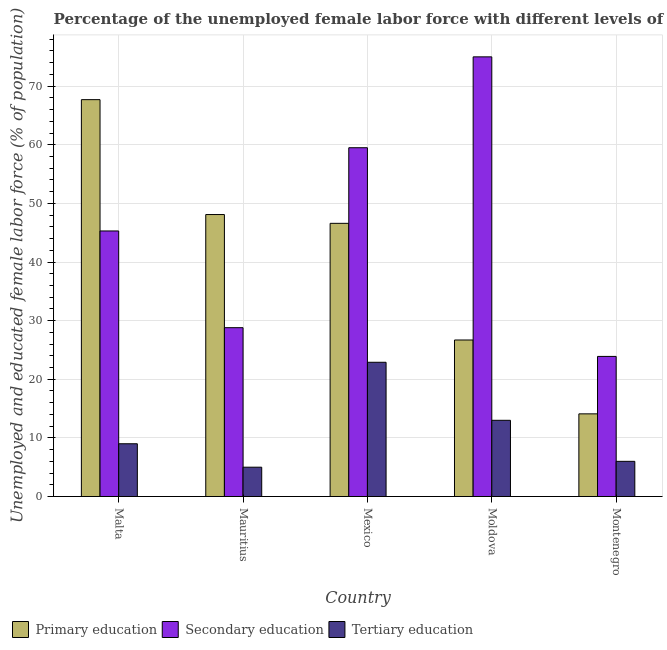Are the number of bars on each tick of the X-axis equal?
Provide a short and direct response. Yes. What is the label of the 5th group of bars from the left?
Provide a short and direct response. Montenegro. In how many cases, is the number of bars for a given country not equal to the number of legend labels?
Your answer should be very brief. 0. What is the percentage of female labor force who received secondary education in Malta?
Your answer should be compact. 45.3. Across all countries, what is the maximum percentage of female labor force who received secondary education?
Keep it short and to the point. 75. Across all countries, what is the minimum percentage of female labor force who received tertiary education?
Give a very brief answer. 5. In which country was the percentage of female labor force who received tertiary education minimum?
Provide a short and direct response. Mauritius. What is the total percentage of female labor force who received secondary education in the graph?
Offer a very short reply. 232.5. What is the difference between the percentage of female labor force who received primary education in Mauritius and that in Moldova?
Offer a terse response. 21.4. What is the average percentage of female labor force who received secondary education per country?
Your response must be concise. 46.5. What is the difference between the percentage of female labor force who received tertiary education and percentage of female labor force who received secondary education in Montenegro?
Provide a short and direct response. -17.9. In how many countries, is the percentage of female labor force who received tertiary education greater than 22 %?
Give a very brief answer. 1. What is the ratio of the percentage of female labor force who received primary education in Mexico to that in Moldova?
Provide a succinct answer. 1.75. Is the percentage of female labor force who received tertiary education in Mexico less than that in Montenegro?
Make the answer very short. No. What is the difference between the highest and the second highest percentage of female labor force who received tertiary education?
Your answer should be compact. 9.9. What is the difference between the highest and the lowest percentage of female labor force who received tertiary education?
Keep it short and to the point. 17.9. Is the sum of the percentage of female labor force who received secondary education in Mauritius and Mexico greater than the maximum percentage of female labor force who received tertiary education across all countries?
Give a very brief answer. Yes. What does the 3rd bar from the left in Montenegro represents?
Keep it short and to the point. Tertiary education. What does the 1st bar from the right in Mauritius represents?
Make the answer very short. Tertiary education. Does the graph contain any zero values?
Offer a terse response. No. Does the graph contain grids?
Keep it short and to the point. Yes. Where does the legend appear in the graph?
Keep it short and to the point. Bottom left. How are the legend labels stacked?
Offer a very short reply. Horizontal. What is the title of the graph?
Your answer should be compact. Percentage of the unemployed female labor force with different levels of education in countries. What is the label or title of the X-axis?
Offer a very short reply. Country. What is the label or title of the Y-axis?
Give a very brief answer. Unemployed and educated female labor force (% of population). What is the Unemployed and educated female labor force (% of population) in Primary education in Malta?
Keep it short and to the point. 67.7. What is the Unemployed and educated female labor force (% of population) in Secondary education in Malta?
Offer a very short reply. 45.3. What is the Unemployed and educated female labor force (% of population) in Primary education in Mauritius?
Ensure brevity in your answer.  48.1. What is the Unemployed and educated female labor force (% of population) in Secondary education in Mauritius?
Keep it short and to the point. 28.8. What is the Unemployed and educated female labor force (% of population) of Primary education in Mexico?
Provide a short and direct response. 46.6. What is the Unemployed and educated female labor force (% of population) of Secondary education in Mexico?
Ensure brevity in your answer.  59.5. What is the Unemployed and educated female labor force (% of population) in Tertiary education in Mexico?
Make the answer very short. 22.9. What is the Unemployed and educated female labor force (% of population) of Primary education in Moldova?
Provide a short and direct response. 26.7. What is the Unemployed and educated female labor force (% of population) in Tertiary education in Moldova?
Provide a short and direct response. 13. What is the Unemployed and educated female labor force (% of population) in Primary education in Montenegro?
Your response must be concise. 14.1. What is the Unemployed and educated female labor force (% of population) of Secondary education in Montenegro?
Keep it short and to the point. 23.9. What is the Unemployed and educated female labor force (% of population) of Tertiary education in Montenegro?
Keep it short and to the point. 6. Across all countries, what is the maximum Unemployed and educated female labor force (% of population) in Primary education?
Give a very brief answer. 67.7. Across all countries, what is the maximum Unemployed and educated female labor force (% of population) of Tertiary education?
Offer a very short reply. 22.9. Across all countries, what is the minimum Unemployed and educated female labor force (% of population) in Primary education?
Your answer should be very brief. 14.1. Across all countries, what is the minimum Unemployed and educated female labor force (% of population) in Secondary education?
Offer a very short reply. 23.9. Across all countries, what is the minimum Unemployed and educated female labor force (% of population) in Tertiary education?
Provide a succinct answer. 5. What is the total Unemployed and educated female labor force (% of population) in Primary education in the graph?
Make the answer very short. 203.2. What is the total Unemployed and educated female labor force (% of population) of Secondary education in the graph?
Provide a succinct answer. 232.5. What is the total Unemployed and educated female labor force (% of population) in Tertiary education in the graph?
Keep it short and to the point. 55.9. What is the difference between the Unemployed and educated female labor force (% of population) of Primary education in Malta and that in Mauritius?
Ensure brevity in your answer.  19.6. What is the difference between the Unemployed and educated female labor force (% of population) of Primary education in Malta and that in Mexico?
Offer a very short reply. 21.1. What is the difference between the Unemployed and educated female labor force (% of population) of Secondary education in Malta and that in Mexico?
Offer a terse response. -14.2. What is the difference between the Unemployed and educated female labor force (% of population) in Primary education in Malta and that in Moldova?
Provide a succinct answer. 41. What is the difference between the Unemployed and educated female labor force (% of population) in Secondary education in Malta and that in Moldova?
Offer a terse response. -29.7. What is the difference between the Unemployed and educated female labor force (% of population) of Tertiary education in Malta and that in Moldova?
Give a very brief answer. -4. What is the difference between the Unemployed and educated female labor force (% of population) of Primary education in Malta and that in Montenegro?
Your answer should be compact. 53.6. What is the difference between the Unemployed and educated female labor force (% of population) in Secondary education in Malta and that in Montenegro?
Offer a very short reply. 21.4. What is the difference between the Unemployed and educated female labor force (% of population) of Primary education in Mauritius and that in Mexico?
Provide a succinct answer. 1.5. What is the difference between the Unemployed and educated female labor force (% of population) in Secondary education in Mauritius and that in Mexico?
Keep it short and to the point. -30.7. What is the difference between the Unemployed and educated female labor force (% of population) of Tertiary education in Mauritius and that in Mexico?
Offer a very short reply. -17.9. What is the difference between the Unemployed and educated female labor force (% of population) of Primary education in Mauritius and that in Moldova?
Your answer should be compact. 21.4. What is the difference between the Unemployed and educated female labor force (% of population) in Secondary education in Mauritius and that in Moldova?
Offer a very short reply. -46.2. What is the difference between the Unemployed and educated female labor force (% of population) in Primary education in Mauritius and that in Montenegro?
Keep it short and to the point. 34. What is the difference between the Unemployed and educated female labor force (% of population) in Secondary education in Mexico and that in Moldova?
Keep it short and to the point. -15.5. What is the difference between the Unemployed and educated female labor force (% of population) in Primary education in Mexico and that in Montenegro?
Give a very brief answer. 32.5. What is the difference between the Unemployed and educated female labor force (% of population) of Secondary education in Mexico and that in Montenegro?
Give a very brief answer. 35.6. What is the difference between the Unemployed and educated female labor force (% of population) of Tertiary education in Mexico and that in Montenegro?
Your answer should be very brief. 16.9. What is the difference between the Unemployed and educated female labor force (% of population) of Secondary education in Moldova and that in Montenegro?
Your answer should be compact. 51.1. What is the difference between the Unemployed and educated female labor force (% of population) of Primary education in Malta and the Unemployed and educated female labor force (% of population) of Secondary education in Mauritius?
Your answer should be compact. 38.9. What is the difference between the Unemployed and educated female labor force (% of population) in Primary education in Malta and the Unemployed and educated female labor force (% of population) in Tertiary education in Mauritius?
Ensure brevity in your answer.  62.7. What is the difference between the Unemployed and educated female labor force (% of population) in Secondary education in Malta and the Unemployed and educated female labor force (% of population) in Tertiary education in Mauritius?
Keep it short and to the point. 40.3. What is the difference between the Unemployed and educated female labor force (% of population) of Primary education in Malta and the Unemployed and educated female labor force (% of population) of Secondary education in Mexico?
Offer a very short reply. 8.2. What is the difference between the Unemployed and educated female labor force (% of population) of Primary education in Malta and the Unemployed and educated female labor force (% of population) of Tertiary education in Mexico?
Offer a very short reply. 44.8. What is the difference between the Unemployed and educated female labor force (% of population) in Secondary education in Malta and the Unemployed and educated female labor force (% of population) in Tertiary education in Mexico?
Your answer should be compact. 22.4. What is the difference between the Unemployed and educated female labor force (% of population) in Primary education in Malta and the Unemployed and educated female labor force (% of population) in Secondary education in Moldova?
Give a very brief answer. -7.3. What is the difference between the Unemployed and educated female labor force (% of population) in Primary education in Malta and the Unemployed and educated female labor force (% of population) in Tertiary education in Moldova?
Give a very brief answer. 54.7. What is the difference between the Unemployed and educated female labor force (% of population) in Secondary education in Malta and the Unemployed and educated female labor force (% of population) in Tertiary education in Moldova?
Provide a short and direct response. 32.3. What is the difference between the Unemployed and educated female labor force (% of population) of Primary education in Malta and the Unemployed and educated female labor force (% of population) of Secondary education in Montenegro?
Provide a short and direct response. 43.8. What is the difference between the Unemployed and educated female labor force (% of population) of Primary education in Malta and the Unemployed and educated female labor force (% of population) of Tertiary education in Montenegro?
Your answer should be very brief. 61.7. What is the difference between the Unemployed and educated female labor force (% of population) in Secondary education in Malta and the Unemployed and educated female labor force (% of population) in Tertiary education in Montenegro?
Keep it short and to the point. 39.3. What is the difference between the Unemployed and educated female labor force (% of population) of Primary education in Mauritius and the Unemployed and educated female labor force (% of population) of Secondary education in Mexico?
Your answer should be compact. -11.4. What is the difference between the Unemployed and educated female labor force (% of population) in Primary education in Mauritius and the Unemployed and educated female labor force (% of population) in Tertiary education in Mexico?
Ensure brevity in your answer.  25.2. What is the difference between the Unemployed and educated female labor force (% of population) of Primary education in Mauritius and the Unemployed and educated female labor force (% of population) of Secondary education in Moldova?
Provide a short and direct response. -26.9. What is the difference between the Unemployed and educated female labor force (% of population) in Primary education in Mauritius and the Unemployed and educated female labor force (% of population) in Tertiary education in Moldova?
Provide a succinct answer. 35.1. What is the difference between the Unemployed and educated female labor force (% of population) in Secondary education in Mauritius and the Unemployed and educated female labor force (% of population) in Tertiary education in Moldova?
Offer a very short reply. 15.8. What is the difference between the Unemployed and educated female labor force (% of population) of Primary education in Mauritius and the Unemployed and educated female labor force (% of population) of Secondary education in Montenegro?
Offer a very short reply. 24.2. What is the difference between the Unemployed and educated female labor force (% of population) in Primary education in Mauritius and the Unemployed and educated female labor force (% of population) in Tertiary education in Montenegro?
Make the answer very short. 42.1. What is the difference between the Unemployed and educated female labor force (% of population) in Secondary education in Mauritius and the Unemployed and educated female labor force (% of population) in Tertiary education in Montenegro?
Keep it short and to the point. 22.8. What is the difference between the Unemployed and educated female labor force (% of population) in Primary education in Mexico and the Unemployed and educated female labor force (% of population) in Secondary education in Moldova?
Offer a terse response. -28.4. What is the difference between the Unemployed and educated female labor force (% of population) of Primary education in Mexico and the Unemployed and educated female labor force (% of population) of Tertiary education in Moldova?
Give a very brief answer. 33.6. What is the difference between the Unemployed and educated female labor force (% of population) of Secondary education in Mexico and the Unemployed and educated female labor force (% of population) of Tertiary education in Moldova?
Offer a terse response. 46.5. What is the difference between the Unemployed and educated female labor force (% of population) in Primary education in Mexico and the Unemployed and educated female labor force (% of population) in Secondary education in Montenegro?
Your response must be concise. 22.7. What is the difference between the Unemployed and educated female labor force (% of population) of Primary education in Mexico and the Unemployed and educated female labor force (% of population) of Tertiary education in Montenegro?
Provide a succinct answer. 40.6. What is the difference between the Unemployed and educated female labor force (% of population) of Secondary education in Mexico and the Unemployed and educated female labor force (% of population) of Tertiary education in Montenegro?
Ensure brevity in your answer.  53.5. What is the difference between the Unemployed and educated female labor force (% of population) of Primary education in Moldova and the Unemployed and educated female labor force (% of population) of Secondary education in Montenegro?
Make the answer very short. 2.8. What is the difference between the Unemployed and educated female labor force (% of population) in Primary education in Moldova and the Unemployed and educated female labor force (% of population) in Tertiary education in Montenegro?
Your response must be concise. 20.7. What is the difference between the Unemployed and educated female labor force (% of population) in Secondary education in Moldova and the Unemployed and educated female labor force (% of population) in Tertiary education in Montenegro?
Provide a succinct answer. 69. What is the average Unemployed and educated female labor force (% of population) in Primary education per country?
Your answer should be very brief. 40.64. What is the average Unemployed and educated female labor force (% of population) in Secondary education per country?
Give a very brief answer. 46.5. What is the average Unemployed and educated female labor force (% of population) of Tertiary education per country?
Provide a short and direct response. 11.18. What is the difference between the Unemployed and educated female labor force (% of population) in Primary education and Unemployed and educated female labor force (% of population) in Secondary education in Malta?
Your response must be concise. 22.4. What is the difference between the Unemployed and educated female labor force (% of population) of Primary education and Unemployed and educated female labor force (% of population) of Tertiary education in Malta?
Your answer should be very brief. 58.7. What is the difference between the Unemployed and educated female labor force (% of population) in Secondary education and Unemployed and educated female labor force (% of population) in Tertiary education in Malta?
Give a very brief answer. 36.3. What is the difference between the Unemployed and educated female labor force (% of population) in Primary education and Unemployed and educated female labor force (% of population) in Secondary education in Mauritius?
Offer a terse response. 19.3. What is the difference between the Unemployed and educated female labor force (% of population) of Primary education and Unemployed and educated female labor force (% of population) of Tertiary education in Mauritius?
Ensure brevity in your answer.  43.1. What is the difference between the Unemployed and educated female labor force (% of population) in Secondary education and Unemployed and educated female labor force (% of population) in Tertiary education in Mauritius?
Your answer should be compact. 23.8. What is the difference between the Unemployed and educated female labor force (% of population) in Primary education and Unemployed and educated female labor force (% of population) in Tertiary education in Mexico?
Keep it short and to the point. 23.7. What is the difference between the Unemployed and educated female labor force (% of population) in Secondary education and Unemployed and educated female labor force (% of population) in Tertiary education in Mexico?
Offer a very short reply. 36.6. What is the difference between the Unemployed and educated female labor force (% of population) of Primary education and Unemployed and educated female labor force (% of population) of Secondary education in Moldova?
Make the answer very short. -48.3. What is the difference between the Unemployed and educated female labor force (% of population) in Secondary education and Unemployed and educated female labor force (% of population) in Tertiary education in Montenegro?
Offer a terse response. 17.9. What is the ratio of the Unemployed and educated female labor force (% of population) in Primary education in Malta to that in Mauritius?
Make the answer very short. 1.41. What is the ratio of the Unemployed and educated female labor force (% of population) of Secondary education in Malta to that in Mauritius?
Your answer should be compact. 1.57. What is the ratio of the Unemployed and educated female labor force (% of population) of Tertiary education in Malta to that in Mauritius?
Provide a short and direct response. 1.8. What is the ratio of the Unemployed and educated female labor force (% of population) of Primary education in Malta to that in Mexico?
Your response must be concise. 1.45. What is the ratio of the Unemployed and educated female labor force (% of population) of Secondary education in Malta to that in Mexico?
Provide a succinct answer. 0.76. What is the ratio of the Unemployed and educated female labor force (% of population) in Tertiary education in Malta to that in Mexico?
Your answer should be compact. 0.39. What is the ratio of the Unemployed and educated female labor force (% of population) in Primary education in Malta to that in Moldova?
Provide a short and direct response. 2.54. What is the ratio of the Unemployed and educated female labor force (% of population) of Secondary education in Malta to that in Moldova?
Provide a succinct answer. 0.6. What is the ratio of the Unemployed and educated female labor force (% of population) in Tertiary education in Malta to that in Moldova?
Provide a short and direct response. 0.69. What is the ratio of the Unemployed and educated female labor force (% of population) of Primary education in Malta to that in Montenegro?
Keep it short and to the point. 4.8. What is the ratio of the Unemployed and educated female labor force (% of population) in Secondary education in Malta to that in Montenegro?
Your answer should be compact. 1.9. What is the ratio of the Unemployed and educated female labor force (% of population) of Tertiary education in Malta to that in Montenegro?
Your response must be concise. 1.5. What is the ratio of the Unemployed and educated female labor force (% of population) in Primary education in Mauritius to that in Mexico?
Keep it short and to the point. 1.03. What is the ratio of the Unemployed and educated female labor force (% of population) of Secondary education in Mauritius to that in Mexico?
Make the answer very short. 0.48. What is the ratio of the Unemployed and educated female labor force (% of population) in Tertiary education in Mauritius to that in Mexico?
Your answer should be very brief. 0.22. What is the ratio of the Unemployed and educated female labor force (% of population) in Primary education in Mauritius to that in Moldova?
Your answer should be very brief. 1.8. What is the ratio of the Unemployed and educated female labor force (% of population) in Secondary education in Mauritius to that in Moldova?
Offer a very short reply. 0.38. What is the ratio of the Unemployed and educated female labor force (% of population) in Tertiary education in Mauritius to that in Moldova?
Keep it short and to the point. 0.38. What is the ratio of the Unemployed and educated female labor force (% of population) of Primary education in Mauritius to that in Montenegro?
Offer a terse response. 3.41. What is the ratio of the Unemployed and educated female labor force (% of population) of Secondary education in Mauritius to that in Montenegro?
Keep it short and to the point. 1.21. What is the ratio of the Unemployed and educated female labor force (% of population) in Primary education in Mexico to that in Moldova?
Your answer should be very brief. 1.75. What is the ratio of the Unemployed and educated female labor force (% of population) of Secondary education in Mexico to that in Moldova?
Ensure brevity in your answer.  0.79. What is the ratio of the Unemployed and educated female labor force (% of population) in Tertiary education in Mexico to that in Moldova?
Ensure brevity in your answer.  1.76. What is the ratio of the Unemployed and educated female labor force (% of population) in Primary education in Mexico to that in Montenegro?
Provide a succinct answer. 3.31. What is the ratio of the Unemployed and educated female labor force (% of population) in Secondary education in Mexico to that in Montenegro?
Give a very brief answer. 2.49. What is the ratio of the Unemployed and educated female labor force (% of population) of Tertiary education in Mexico to that in Montenegro?
Provide a succinct answer. 3.82. What is the ratio of the Unemployed and educated female labor force (% of population) in Primary education in Moldova to that in Montenegro?
Offer a very short reply. 1.89. What is the ratio of the Unemployed and educated female labor force (% of population) of Secondary education in Moldova to that in Montenegro?
Ensure brevity in your answer.  3.14. What is the ratio of the Unemployed and educated female labor force (% of population) of Tertiary education in Moldova to that in Montenegro?
Your answer should be compact. 2.17. What is the difference between the highest and the second highest Unemployed and educated female labor force (% of population) of Primary education?
Keep it short and to the point. 19.6. What is the difference between the highest and the second highest Unemployed and educated female labor force (% of population) in Secondary education?
Keep it short and to the point. 15.5. What is the difference between the highest and the lowest Unemployed and educated female labor force (% of population) in Primary education?
Your answer should be compact. 53.6. What is the difference between the highest and the lowest Unemployed and educated female labor force (% of population) of Secondary education?
Provide a short and direct response. 51.1. What is the difference between the highest and the lowest Unemployed and educated female labor force (% of population) in Tertiary education?
Make the answer very short. 17.9. 